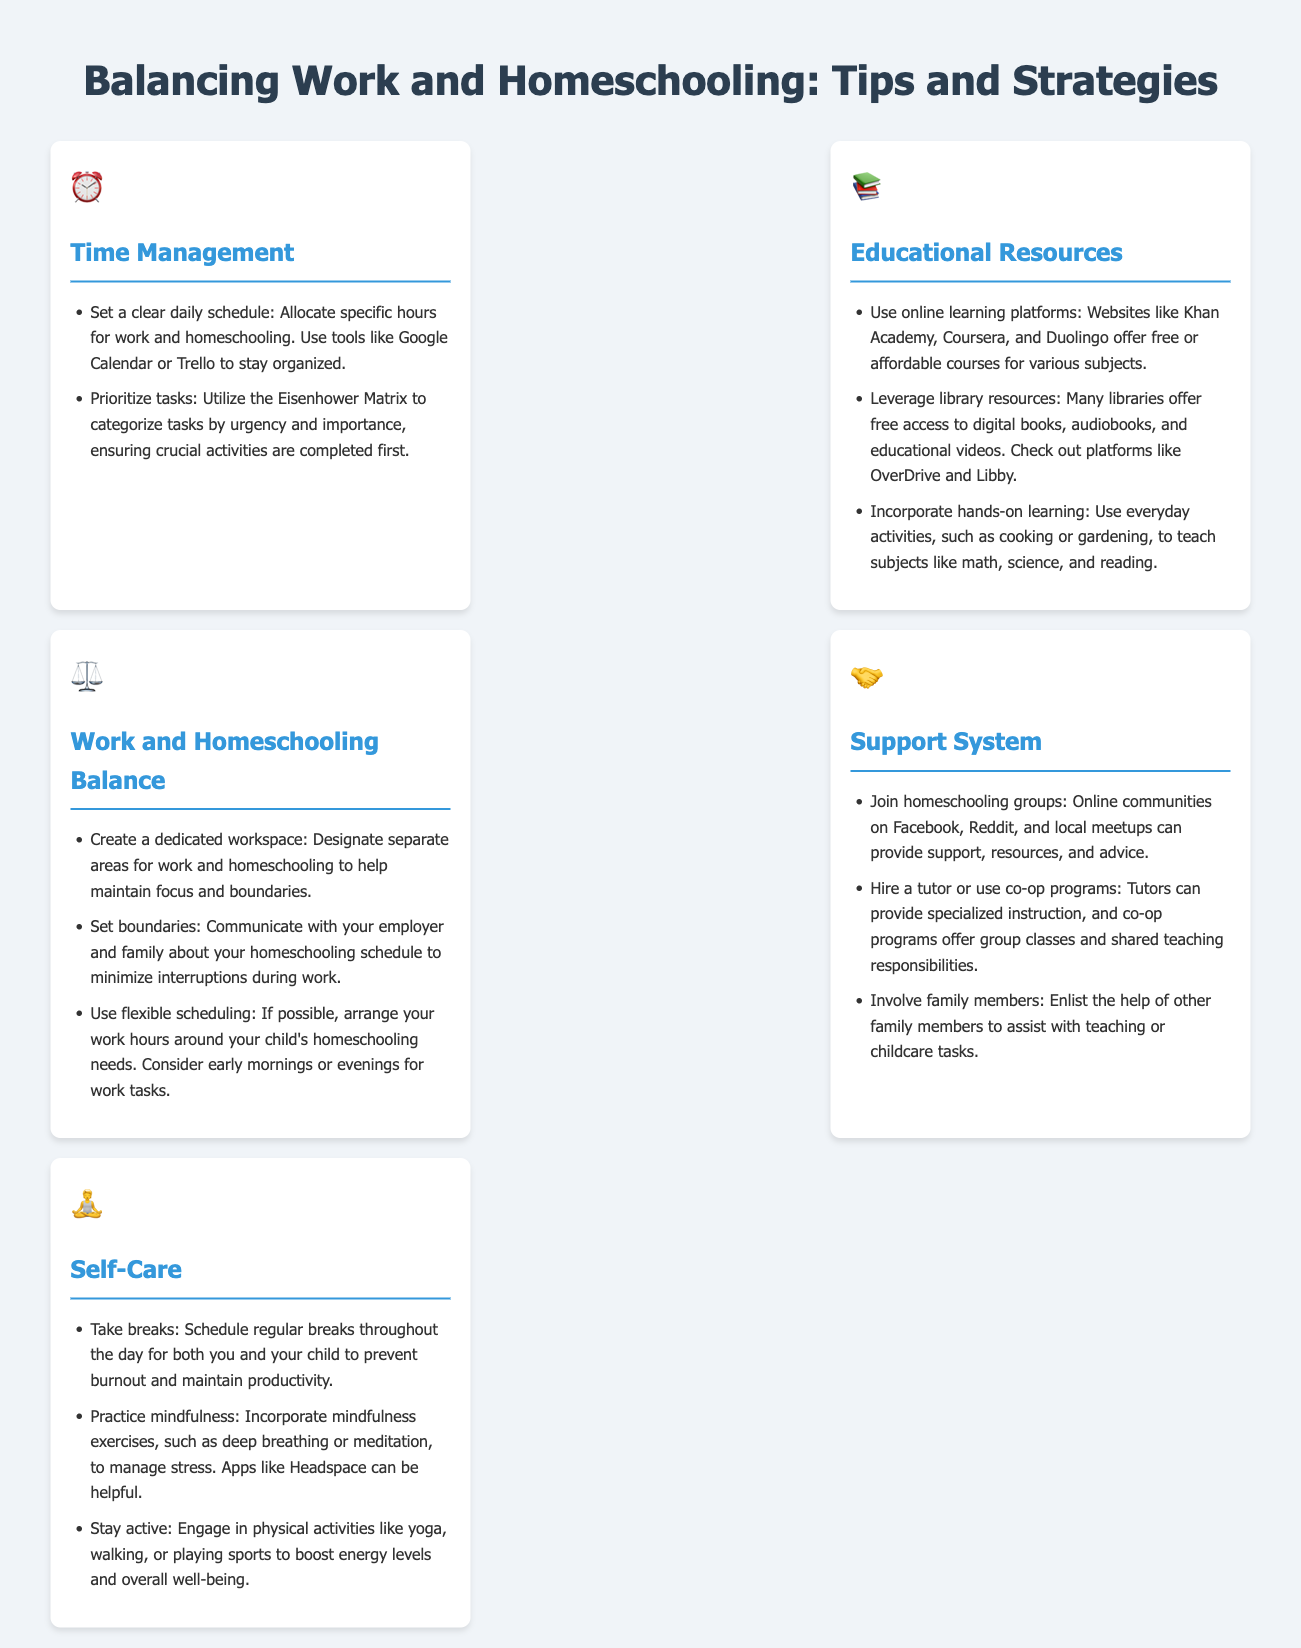What is the icon for time management? The icon representing time management is a clock.
Answer: Clock How many key sections are in the infographic? The infographic contains five sections, each addressing different aspects of balancing work and homeschooling.
Answer: Five What platform is suggested for online learning? The infographic mentions Khan Academy as a recommended online learning platform.
Answer: Khan Academy What should you create to help maintain focus during work and homeschooling? Establishing a dedicated workspace is recommended to maintain focus and boundaries.
Answer: Dedicated workspace What exercise is suggested to help manage stress? Mindfulness exercises, such as deep breathing or meditation, are suggested for managing stress.
Answer: Mindfulness exercises What is a useful tool for scheduling tasks? Google Calendar is mentioned as a useful tool for scheduling tasks.
Answer: Google Calendar How can family members contribute to homeschooling? Family members can assist with teaching or childcare tasks.
Answer: Assist with teaching or childcare What can be incorporated into daily activities for hands-on learning? Everyday activities like cooking or gardening can be incorporated for hands-on learning.
Answer: Cooking or gardening 